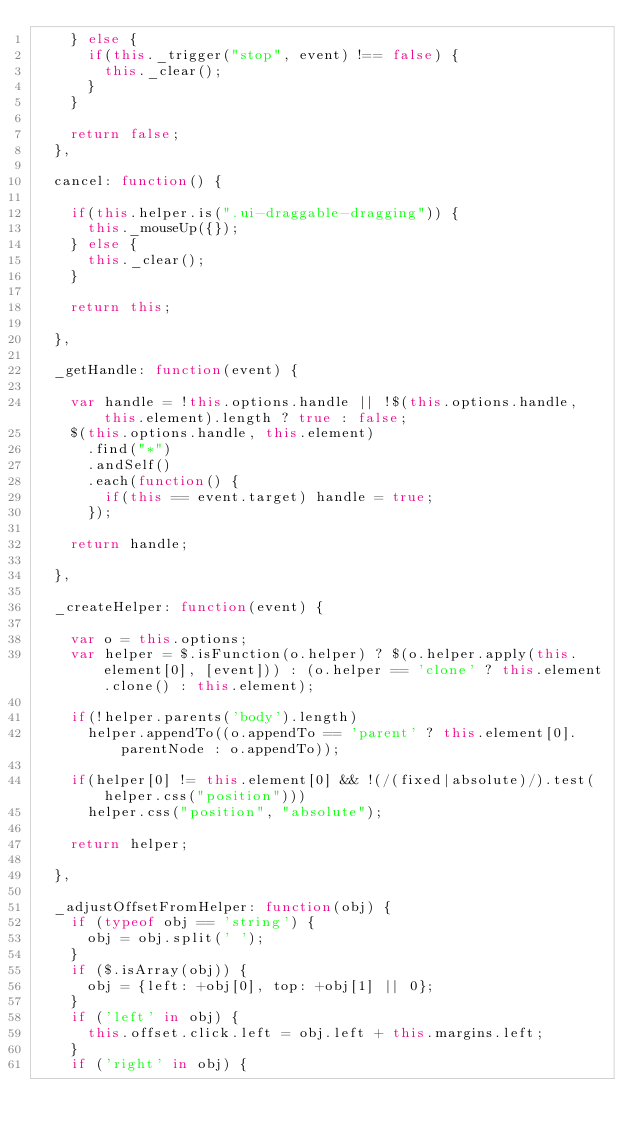<code> <loc_0><loc_0><loc_500><loc_500><_JavaScript_>		} else {
			if(this._trigger("stop", event) !== false) {
				this._clear();
			}
		}

		return false;
	},
	
	cancel: function() {
		
		if(this.helper.is(".ui-draggable-dragging")) {
			this._mouseUp({});
		} else {
			this._clear();
		}
		
		return this;
		
	},

	_getHandle: function(event) {

		var handle = !this.options.handle || !$(this.options.handle, this.element).length ? true : false;
		$(this.options.handle, this.element)
			.find("*")
			.andSelf()
			.each(function() {
				if(this == event.target) handle = true;
			});

		return handle;

	},

	_createHelper: function(event) {

		var o = this.options;
		var helper = $.isFunction(o.helper) ? $(o.helper.apply(this.element[0], [event])) : (o.helper == 'clone' ? this.element.clone() : this.element);

		if(!helper.parents('body').length)
			helper.appendTo((o.appendTo == 'parent' ? this.element[0].parentNode : o.appendTo));

		if(helper[0] != this.element[0] && !(/(fixed|absolute)/).test(helper.css("position")))
			helper.css("position", "absolute");

		return helper;

	},

	_adjustOffsetFromHelper: function(obj) {
		if (typeof obj == 'string') {
			obj = obj.split(' ');
		}
		if ($.isArray(obj)) {
			obj = {left: +obj[0], top: +obj[1] || 0};
		}
		if ('left' in obj) {
			this.offset.click.left = obj.left + this.margins.left;
		}
		if ('right' in obj) {</code> 